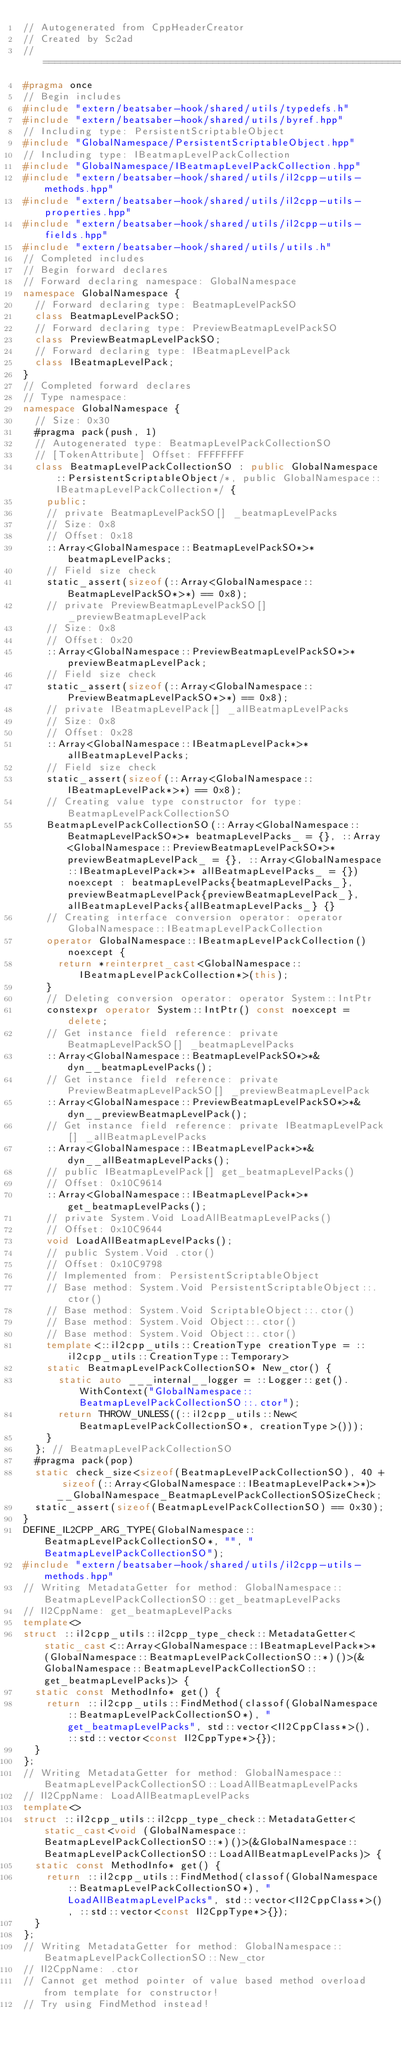Convert code to text. <code><loc_0><loc_0><loc_500><loc_500><_C++_>// Autogenerated from CppHeaderCreator
// Created by Sc2ad
// =========================================================================
#pragma once
// Begin includes
#include "extern/beatsaber-hook/shared/utils/typedefs.h"
#include "extern/beatsaber-hook/shared/utils/byref.hpp"
// Including type: PersistentScriptableObject
#include "GlobalNamespace/PersistentScriptableObject.hpp"
// Including type: IBeatmapLevelPackCollection
#include "GlobalNamespace/IBeatmapLevelPackCollection.hpp"
#include "extern/beatsaber-hook/shared/utils/il2cpp-utils-methods.hpp"
#include "extern/beatsaber-hook/shared/utils/il2cpp-utils-properties.hpp"
#include "extern/beatsaber-hook/shared/utils/il2cpp-utils-fields.hpp"
#include "extern/beatsaber-hook/shared/utils/utils.h"
// Completed includes
// Begin forward declares
// Forward declaring namespace: GlobalNamespace
namespace GlobalNamespace {
  // Forward declaring type: BeatmapLevelPackSO
  class BeatmapLevelPackSO;
  // Forward declaring type: PreviewBeatmapLevelPackSO
  class PreviewBeatmapLevelPackSO;
  // Forward declaring type: IBeatmapLevelPack
  class IBeatmapLevelPack;
}
// Completed forward declares
// Type namespace: 
namespace GlobalNamespace {
  // Size: 0x30
  #pragma pack(push, 1)
  // Autogenerated type: BeatmapLevelPackCollectionSO
  // [TokenAttribute] Offset: FFFFFFFF
  class BeatmapLevelPackCollectionSO : public GlobalNamespace::PersistentScriptableObject/*, public GlobalNamespace::IBeatmapLevelPackCollection*/ {
    public:
    // private BeatmapLevelPackSO[] _beatmapLevelPacks
    // Size: 0x8
    // Offset: 0x18
    ::Array<GlobalNamespace::BeatmapLevelPackSO*>* beatmapLevelPacks;
    // Field size check
    static_assert(sizeof(::Array<GlobalNamespace::BeatmapLevelPackSO*>*) == 0x8);
    // private PreviewBeatmapLevelPackSO[] _previewBeatmapLevelPack
    // Size: 0x8
    // Offset: 0x20
    ::Array<GlobalNamespace::PreviewBeatmapLevelPackSO*>* previewBeatmapLevelPack;
    // Field size check
    static_assert(sizeof(::Array<GlobalNamespace::PreviewBeatmapLevelPackSO*>*) == 0x8);
    // private IBeatmapLevelPack[] _allBeatmapLevelPacks
    // Size: 0x8
    // Offset: 0x28
    ::Array<GlobalNamespace::IBeatmapLevelPack*>* allBeatmapLevelPacks;
    // Field size check
    static_assert(sizeof(::Array<GlobalNamespace::IBeatmapLevelPack*>*) == 0x8);
    // Creating value type constructor for type: BeatmapLevelPackCollectionSO
    BeatmapLevelPackCollectionSO(::Array<GlobalNamespace::BeatmapLevelPackSO*>* beatmapLevelPacks_ = {}, ::Array<GlobalNamespace::PreviewBeatmapLevelPackSO*>* previewBeatmapLevelPack_ = {}, ::Array<GlobalNamespace::IBeatmapLevelPack*>* allBeatmapLevelPacks_ = {}) noexcept : beatmapLevelPacks{beatmapLevelPacks_}, previewBeatmapLevelPack{previewBeatmapLevelPack_}, allBeatmapLevelPacks{allBeatmapLevelPacks_} {}
    // Creating interface conversion operator: operator GlobalNamespace::IBeatmapLevelPackCollection
    operator GlobalNamespace::IBeatmapLevelPackCollection() noexcept {
      return *reinterpret_cast<GlobalNamespace::IBeatmapLevelPackCollection*>(this);
    }
    // Deleting conversion operator: operator System::IntPtr
    constexpr operator System::IntPtr() const noexcept = delete;
    // Get instance field reference: private BeatmapLevelPackSO[] _beatmapLevelPacks
    ::Array<GlobalNamespace::BeatmapLevelPackSO*>*& dyn__beatmapLevelPacks();
    // Get instance field reference: private PreviewBeatmapLevelPackSO[] _previewBeatmapLevelPack
    ::Array<GlobalNamespace::PreviewBeatmapLevelPackSO*>*& dyn__previewBeatmapLevelPack();
    // Get instance field reference: private IBeatmapLevelPack[] _allBeatmapLevelPacks
    ::Array<GlobalNamespace::IBeatmapLevelPack*>*& dyn__allBeatmapLevelPacks();
    // public IBeatmapLevelPack[] get_beatmapLevelPacks()
    // Offset: 0x10C9614
    ::Array<GlobalNamespace::IBeatmapLevelPack*>* get_beatmapLevelPacks();
    // private System.Void LoadAllBeatmapLevelPacks()
    // Offset: 0x10C9644
    void LoadAllBeatmapLevelPacks();
    // public System.Void .ctor()
    // Offset: 0x10C9798
    // Implemented from: PersistentScriptableObject
    // Base method: System.Void PersistentScriptableObject::.ctor()
    // Base method: System.Void ScriptableObject::.ctor()
    // Base method: System.Void Object::.ctor()
    // Base method: System.Void Object::.ctor()
    template<::il2cpp_utils::CreationType creationType = ::il2cpp_utils::CreationType::Temporary>
    static BeatmapLevelPackCollectionSO* New_ctor() {
      static auto ___internal__logger = ::Logger::get().WithContext("GlobalNamespace::BeatmapLevelPackCollectionSO::.ctor");
      return THROW_UNLESS((::il2cpp_utils::New<BeatmapLevelPackCollectionSO*, creationType>()));
    }
  }; // BeatmapLevelPackCollectionSO
  #pragma pack(pop)
  static check_size<sizeof(BeatmapLevelPackCollectionSO), 40 + sizeof(::Array<GlobalNamespace::IBeatmapLevelPack*>*)> __GlobalNamespace_BeatmapLevelPackCollectionSOSizeCheck;
  static_assert(sizeof(BeatmapLevelPackCollectionSO) == 0x30);
}
DEFINE_IL2CPP_ARG_TYPE(GlobalNamespace::BeatmapLevelPackCollectionSO*, "", "BeatmapLevelPackCollectionSO");
#include "extern/beatsaber-hook/shared/utils/il2cpp-utils-methods.hpp"
// Writing MetadataGetter for method: GlobalNamespace::BeatmapLevelPackCollectionSO::get_beatmapLevelPacks
// Il2CppName: get_beatmapLevelPacks
template<>
struct ::il2cpp_utils::il2cpp_type_check::MetadataGetter<static_cast<::Array<GlobalNamespace::IBeatmapLevelPack*>* (GlobalNamespace::BeatmapLevelPackCollectionSO::*)()>(&GlobalNamespace::BeatmapLevelPackCollectionSO::get_beatmapLevelPacks)> {
  static const MethodInfo* get() {
    return ::il2cpp_utils::FindMethod(classof(GlobalNamespace::BeatmapLevelPackCollectionSO*), "get_beatmapLevelPacks", std::vector<Il2CppClass*>(), ::std::vector<const Il2CppType*>{});
  }
};
// Writing MetadataGetter for method: GlobalNamespace::BeatmapLevelPackCollectionSO::LoadAllBeatmapLevelPacks
// Il2CppName: LoadAllBeatmapLevelPacks
template<>
struct ::il2cpp_utils::il2cpp_type_check::MetadataGetter<static_cast<void (GlobalNamespace::BeatmapLevelPackCollectionSO::*)()>(&GlobalNamespace::BeatmapLevelPackCollectionSO::LoadAllBeatmapLevelPacks)> {
  static const MethodInfo* get() {
    return ::il2cpp_utils::FindMethod(classof(GlobalNamespace::BeatmapLevelPackCollectionSO*), "LoadAllBeatmapLevelPacks", std::vector<Il2CppClass*>(), ::std::vector<const Il2CppType*>{});
  }
};
// Writing MetadataGetter for method: GlobalNamespace::BeatmapLevelPackCollectionSO::New_ctor
// Il2CppName: .ctor
// Cannot get method pointer of value based method overload from template for constructor!
// Try using FindMethod instead!
</code> 